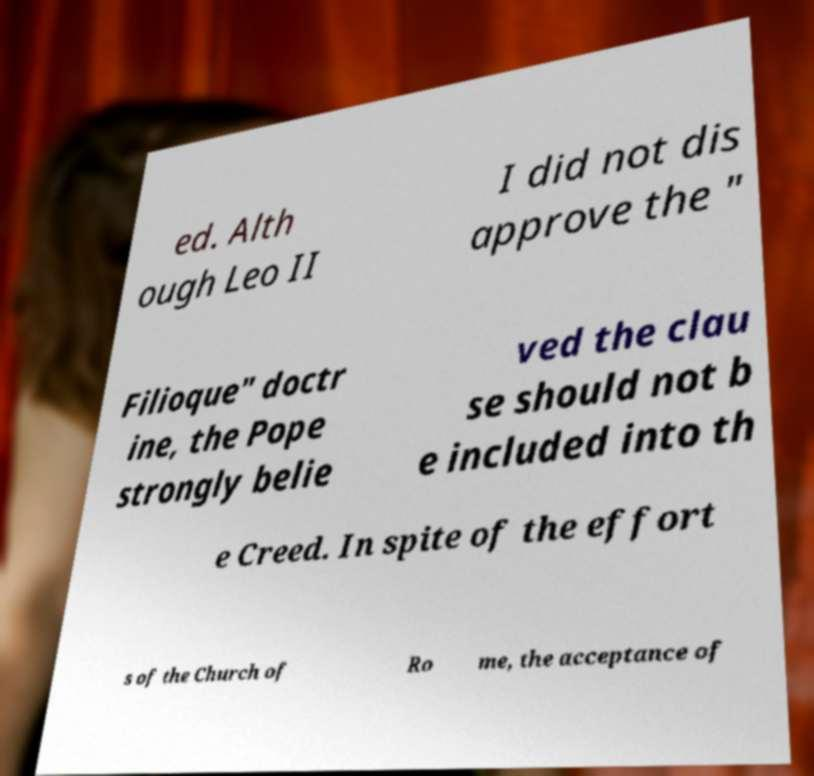What messages or text are displayed in this image? I need them in a readable, typed format. ed. Alth ough Leo II I did not dis approve the " Filioque" doctr ine, the Pope strongly belie ved the clau se should not b e included into th e Creed. In spite of the effort s of the Church of Ro me, the acceptance of 